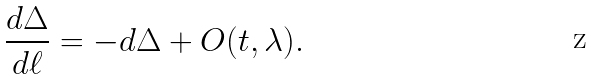<formula> <loc_0><loc_0><loc_500><loc_500>\frac { d \Delta } { d \ell } = - d \Delta + O ( t , \lambda ) .</formula> 